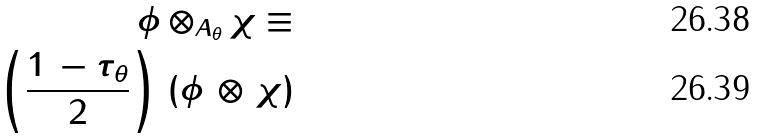Convert formula to latex. <formula><loc_0><loc_0><loc_500><loc_500>\phi \otimes _ { A _ { \theta } } \chi \equiv \\ \left ( \frac { 1 \, - \tau _ { \theta } } { 2 } \right ) \, ( \phi \, \otimes \, \chi )</formula> 